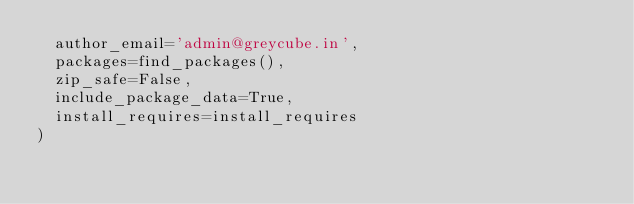<code> <loc_0><loc_0><loc_500><loc_500><_Python_>	author_email='admin@greycube.in',
	packages=find_packages(),
	zip_safe=False,
	include_package_data=True,
	install_requires=install_requires
)
</code> 